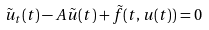<formula> <loc_0><loc_0><loc_500><loc_500>\tilde { u } _ { t } ( t ) - A \tilde { u } ( t ) + \tilde { f } ( t , u ( t ) ) = 0</formula> 